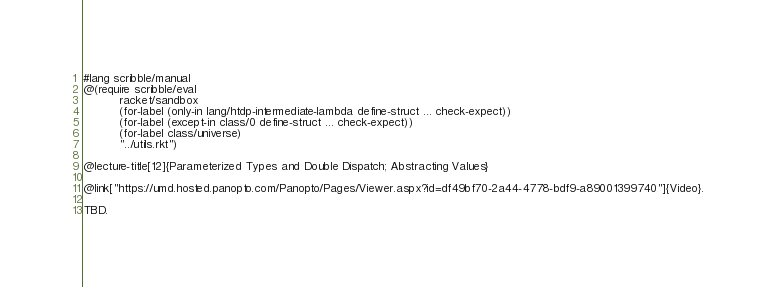Convert code to text. <code><loc_0><loc_0><loc_500><loc_500><_Racket_>#lang scribble/manual
@(require scribble/eval
          racket/sandbox
          (for-label (only-in lang/htdp-intermediate-lambda define-struct ... check-expect))
          (for-label (except-in class/0 define-struct ... check-expect))
          (for-label class/universe)
          "../utils.rkt")

@lecture-title[12]{Parameterized Types and Double Dispatch; Abstracting Values}

@link["https://umd.hosted.panopto.com/Panopto/Pages/Viewer.aspx?id=df49bf70-2a44-4778-bdf9-a89001399740"]{Video}.

TBD.</code> 